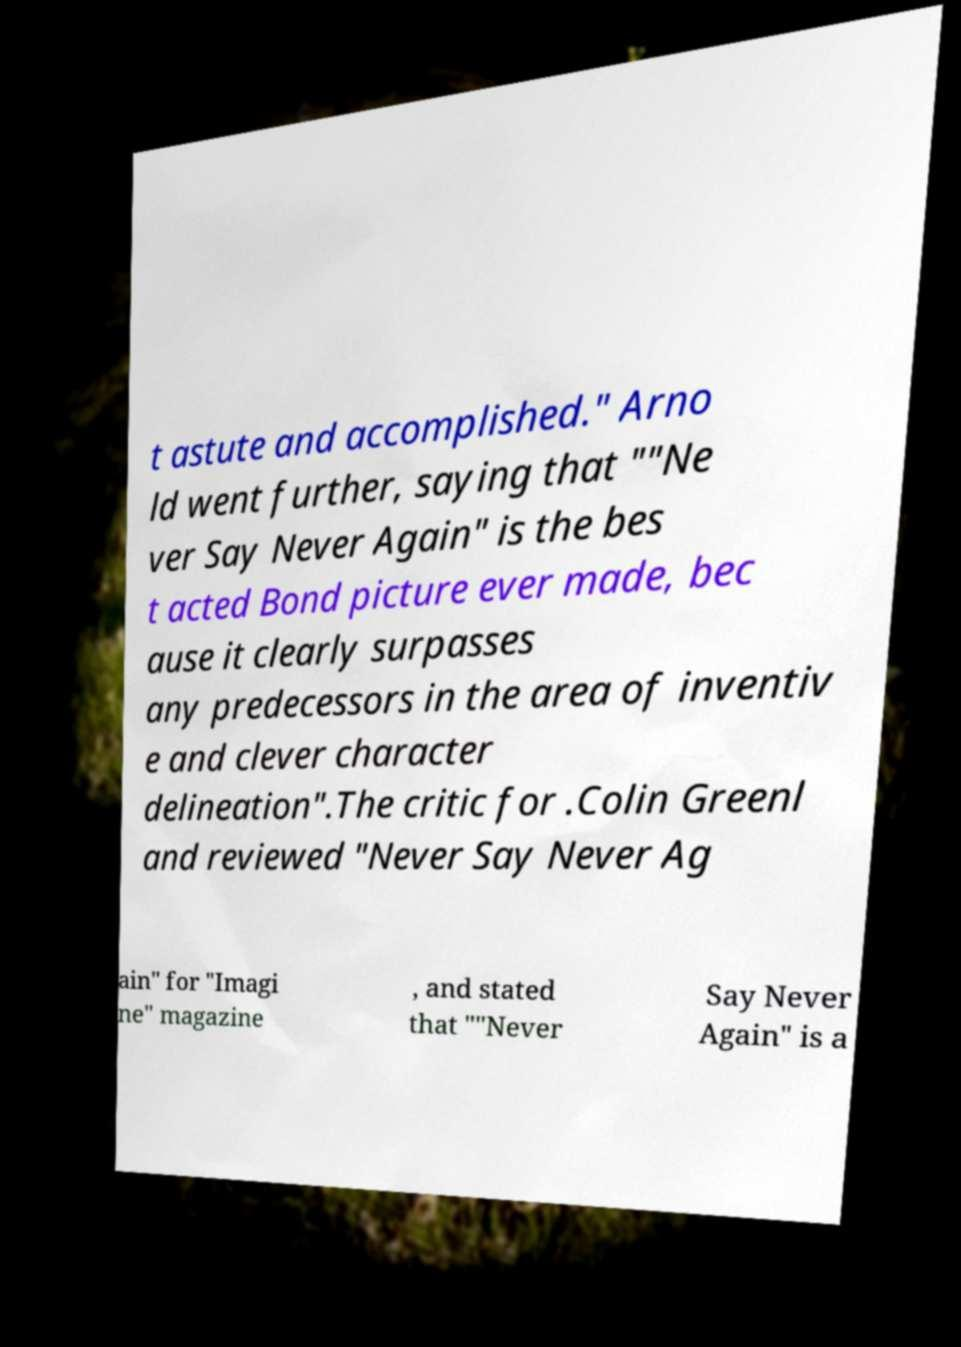Please read and relay the text visible in this image. What does it say? t astute and accomplished." Arno ld went further, saying that ""Ne ver Say Never Again" is the bes t acted Bond picture ever made, bec ause it clearly surpasses any predecessors in the area of inventiv e and clever character delineation".The critic for .Colin Greenl and reviewed "Never Say Never Ag ain" for "Imagi ne" magazine , and stated that ""Never Say Never Again" is a 